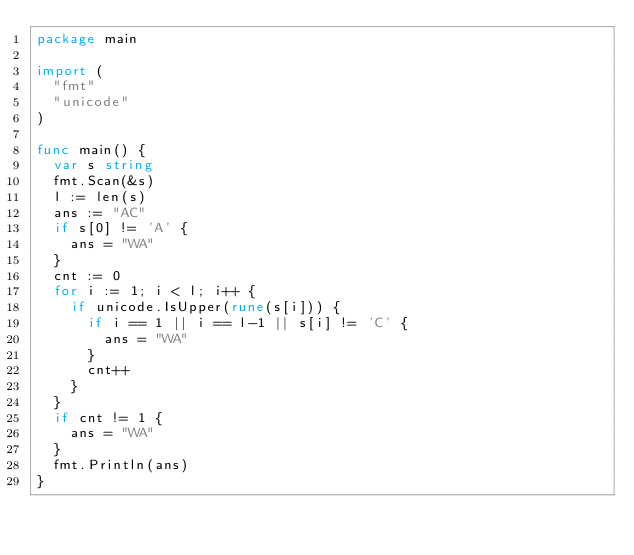Convert code to text. <code><loc_0><loc_0><loc_500><loc_500><_Go_>package main

import (
	"fmt"
	"unicode"
)

func main() {
	var s string
	fmt.Scan(&s)
	l := len(s)
	ans := "AC"
	if s[0] != 'A' {
		ans = "WA"
	}
	cnt := 0
	for i := 1; i < l; i++ {
		if unicode.IsUpper(rune(s[i])) {
			if i == 1 || i == l-1 || s[i] != 'C' {
				ans = "WA"
			}
			cnt++
		}
	}
	if cnt != 1 {
		ans = "WA"
	}
	fmt.Println(ans)
}
</code> 